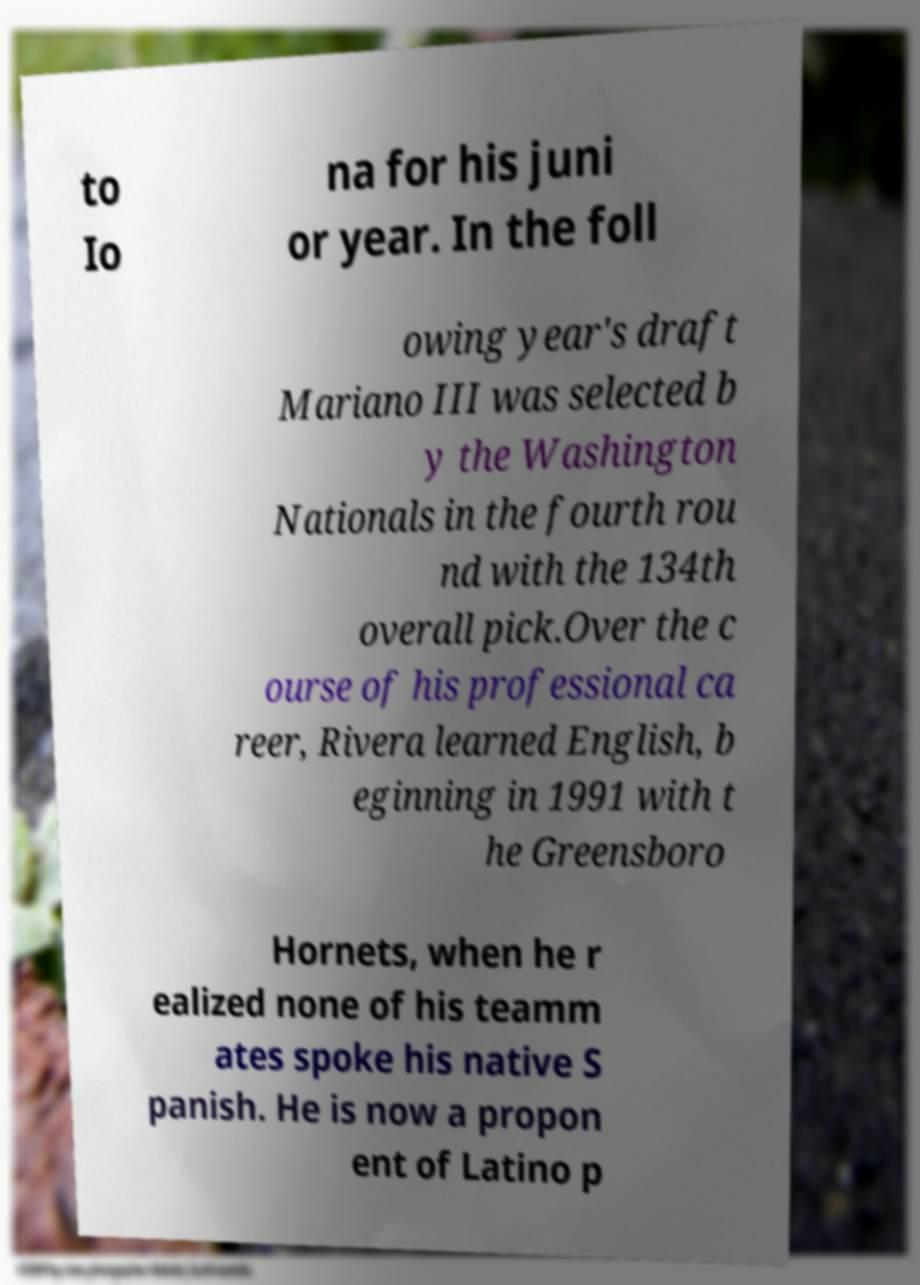Can you read and provide the text displayed in the image?This photo seems to have some interesting text. Can you extract and type it out for me? to Io na for his juni or year. In the foll owing year's draft Mariano III was selected b y the Washington Nationals in the fourth rou nd with the 134th overall pick.Over the c ourse of his professional ca reer, Rivera learned English, b eginning in 1991 with t he Greensboro Hornets, when he r ealized none of his teamm ates spoke his native S panish. He is now a propon ent of Latino p 